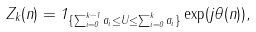Convert formula to latex. <formula><loc_0><loc_0><loc_500><loc_500>Z _ { k } ( n ) = 1 _ { \{ \sum _ { i = 0 } ^ { k - 1 } a _ { i } \leq U \leq \sum _ { i = 0 } ^ { k } a _ { i } \} } \exp ( j \theta ( n ) ) ,</formula> 